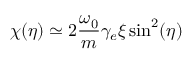<formula> <loc_0><loc_0><loc_500><loc_500>\chi ( \eta ) \simeq 2 \frac { \omega _ { 0 } } { m } \gamma _ { e } \xi \sin ^ { 2 } ( \eta )</formula> 